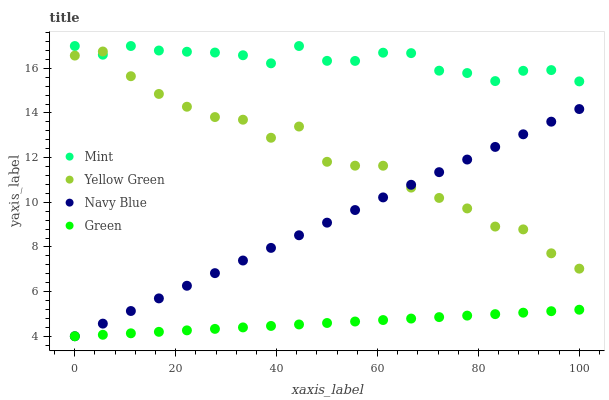Does Green have the minimum area under the curve?
Answer yes or no. Yes. Does Mint have the maximum area under the curve?
Answer yes or no. Yes. Does Mint have the minimum area under the curve?
Answer yes or no. No. Does Green have the maximum area under the curve?
Answer yes or no. No. Is Green the smoothest?
Answer yes or no. Yes. Is Yellow Green the roughest?
Answer yes or no. Yes. Is Mint the smoothest?
Answer yes or no. No. Is Mint the roughest?
Answer yes or no. No. Does Navy Blue have the lowest value?
Answer yes or no. Yes. Does Mint have the lowest value?
Answer yes or no. No. Does Mint have the highest value?
Answer yes or no. Yes. Does Green have the highest value?
Answer yes or no. No. Is Green less than Yellow Green?
Answer yes or no. Yes. Is Yellow Green greater than Green?
Answer yes or no. Yes. Does Yellow Green intersect Navy Blue?
Answer yes or no. Yes. Is Yellow Green less than Navy Blue?
Answer yes or no. No. Is Yellow Green greater than Navy Blue?
Answer yes or no. No. Does Green intersect Yellow Green?
Answer yes or no. No. 